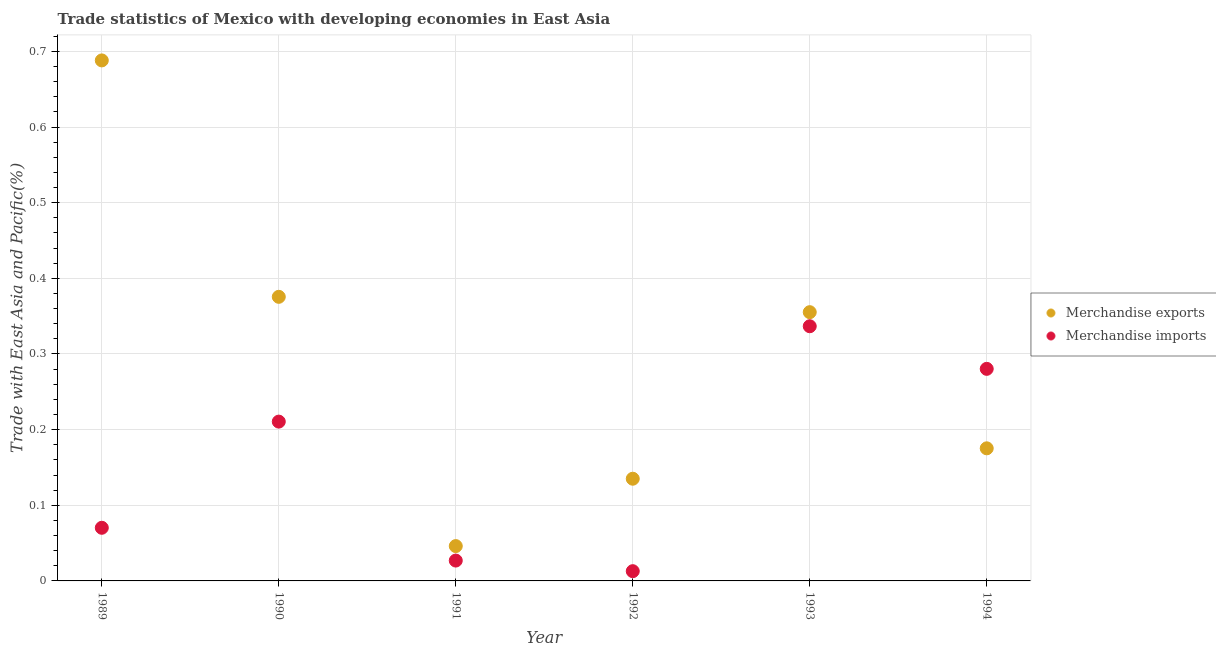What is the merchandise imports in 1993?
Offer a terse response. 0.34. Across all years, what is the maximum merchandise imports?
Provide a succinct answer. 0.34. Across all years, what is the minimum merchandise exports?
Keep it short and to the point. 0.05. In which year was the merchandise exports minimum?
Provide a succinct answer. 1991. What is the total merchandise exports in the graph?
Give a very brief answer. 1.78. What is the difference between the merchandise imports in 1989 and that in 1991?
Offer a very short reply. 0.04. What is the difference between the merchandise exports in 1993 and the merchandise imports in 1992?
Your response must be concise. 0.34. What is the average merchandise exports per year?
Give a very brief answer. 0.3. In the year 1994, what is the difference between the merchandise exports and merchandise imports?
Make the answer very short. -0.11. In how many years, is the merchandise exports greater than 0.6000000000000001 %?
Your response must be concise. 1. What is the ratio of the merchandise exports in 1992 to that in 1993?
Provide a succinct answer. 0.38. What is the difference between the highest and the second highest merchandise imports?
Give a very brief answer. 0.06. What is the difference between the highest and the lowest merchandise exports?
Your answer should be compact. 0.64. In how many years, is the merchandise imports greater than the average merchandise imports taken over all years?
Provide a short and direct response. 3. Does the merchandise exports monotonically increase over the years?
Your response must be concise. No. Is the merchandise exports strictly less than the merchandise imports over the years?
Provide a succinct answer. No. Does the graph contain grids?
Your answer should be very brief. Yes. Where does the legend appear in the graph?
Make the answer very short. Center right. How many legend labels are there?
Keep it short and to the point. 2. What is the title of the graph?
Ensure brevity in your answer.  Trade statistics of Mexico with developing economies in East Asia. Does "Register a property" appear as one of the legend labels in the graph?
Keep it short and to the point. No. What is the label or title of the X-axis?
Make the answer very short. Year. What is the label or title of the Y-axis?
Provide a short and direct response. Trade with East Asia and Pacific(%). What is the Trade with East Asia and Pacific(%) of Merchandise exports in 1989?
Give a very brief answer. 0.69. What is the Trade with East Asia and Pacific(%) in Merchandise imports in 1989?
Your answer should be very brief. 0.07. What is the Trade with East Asia and Pacific(%) of Merchandise exports in 1990?
Offer a terse response. 0.38. What is the Trade with East Asia and Pacific(%) of Merchandise imports in 1990?
Your response must be concise. 0.21. What is the Trade with East Asia and Pacific(%) in Merchandise exports in 1991?
Your answer should be very brief. 0.05. What is the Trade with East Asia and Pacific(%) of Merchandise imports in 1991?
Your answer should be very brief. 0.03. What is the Trade with East Asia and Pacific(%) of Merchandise exports in 1992?
Offer a terse response. 0.14. What is the Trade with East Asia and Pacific(%) in Merchandise imports in 1992?
Your response must be concise. 0.01. What is the Trade with East Asia and Pacific(%) of Merchandise exports in 1993?
Ensure brevity in your answer.  0.36. What is the Trade with East Asia and Pacific(%) in Merchandise imports in 1993?
Give a very brief answer. 0.34. What is the Trade with East Asia and Pacific(%) of Merchandise exports in 1994?
Provide a short and direct response. 0.18. What is the Trade with East Asia and Pacific(%) of Merchandise imports in 1994?
Provide a short and direct response. 0.28. Across all years, what is the maximum Trade with East Asia and Pacific(%) in Merchandise exports?
Provide a succinct answer. 0.69. Across all years, what is the maximum Trade with East Asia and Pacific(%) of Merchandise imports?
Ensure brevity in your answer.  0.34. Across all years, what is the minimum Trade with East Asia and Pacific(%) in Merchandise exports?
Your response must be concise. 0.05. Across all years, what is the minimum Trade with East Asia and Pacific(%) of Merchandise imports?
Your response must be concise. 0.01. What is the total Trade with East Asia and Pacific(%) of Merchandise exports in the graph?
Provide a short and direct response. 1.78. What is the total Trade with East Asia and Pacific(%) in Merchandise imports in the graph?
Your answer should be very brief. 0.94. What is the difference between the Trade with East Asia and Pacific(%) in Merchandise exports in 1989 and that in 1990?
Your response must be concise. 0.31. What is the difference between the Trade with East Asia and Pacific(%) in Merchandise imports in 1989 and that in 1990?
Give a very brief answer. -0.14. What is the difference between the Trade with East Asia and Pacific(%) in Merchandise exports in 1989 and that in 1991?
Your answer should be compact. 0.64. What is the difference between the Trade with East Asia and Pacific(%) in Merchandise imports in 1989 and that in 1991?
Your answer should be very brief. 0.04. What is the difference between the Trade with East Asia and Pacific(%) of Merchandise exports in 1989 and that in 1992?
Ensure brevity in your answer.  0.55. What is the difference between the Trade with East Asia and Pacific(%) of Merchandise imports in 1989 and that in 1992?
Offer a very short reply. 0.06. What is the difference between the Trade with East Asia and Pacific(%) in Merchandise exports in 1989 and that in 1993?
Give a very brief answer. 0.33. What is the difference between the Trade with East Asia and Pacific(%) of Merchandise imports in 1989 and that in 1993?
Provide a succinct answer. -0.27. What is the difference between the Trade with East Asia and Pacific(%) of Merchandise exports in 1989 and that in 1994?
Keep it short and to the point. 0.51. What is the difference between the Trade with East Asia and Pacific(%) of Merchandise imports in 1989 and that in 1994?
Ensure brevity in your answer.  -0.21. What is the difference between the Trade with East Asia and Pacific(%) of Merchandise exports in 1990 and that in 1991?
Provide a short and direct response. 0.33. What is the difference between the Trade with East Asia and Pacific(%) in Merchandise imports in 1990 and that in 1991?
Your response must be concise. 0.18. What is the difference between the Trade with East Asia and Pacific(%) of Merchandise exports in 1990 and that in 1992?
Give a very brief answer. 0.24. What is the difference between the Trade with East Asia and Pacific(%) of Merchandise imports in 1990 and that in 1992?
Your answer should be very brief. 0.2. What is the difference between the Trade with East Asia and Pacific(%) of Merchandise exports in 1990 and that in 1993?
Offer a terse response. 0.02. What is the difference between the Trade with East Asia and Pacific(%) in Merchandise imports in 1990 and that in 1993?
Provide a short and direct response. -0.13. What is the difference between the Trade with East Asia and Pacific(%) in Merchandise exports in 1990 and that in 1994?
Your response must be concise. 0.2. What is the difference between the Trade with East Asia and Pacific(%) in Merchandise imports in 1990 and that in 1994?
Give a very brief answer. -0.07. What is the difference between the Trade with East Asia and Pacific(%) of Merchandise exports in 1991 and that in 1992?
Make the answer very short. -0.09. What is the difference between the Trade with East Asia and Pacific(%) of Merchandise imports in 1991 and that in 1992?
Provide a short and direct response. 0.01. What is the difference between the Trade with East Asia and Pacific(%) of Merchandise exports in 1991 and that in 1993?
Your response must be concise. -0.31. What is the difference between the Trade with East Asia and Pacific(%) of Merchandise imports in 1991 and that in 1993?
Give a very brief answer. -0.31. What is the difference between the Trade with East Asia and Pacific(%) in Merchandise exports in 1991 and that in 1994?
Ensure brevity in your answer.  -0.13. What is the difference between the Trade with East Asia and Pacific(%) in Merchandise imports in 1991 and that in 1994?
Your answer should be compact. -0.25. What is the difference between the Trade with East Asia and Pacific(%) of Merchandise exports in 1992 and that in 1993?
Your response must be concise. -0.22. What is the difference between the Trade with East Asia and Pacific(%) in Merchandise imports in 1992 and that in 1993?
Give a very brief answer. -0.32. What is the difference between the Trade with East Asia and Pacific(%) in Merchandise exports in 1992 and that in 1994?
Provide a short and direct response. -0.04. What is the difference between the Trade with East Asia and Pacific(%) of Merchandise imports in 1992 and that in 1994?
Provide a succinct answer. -0.27. What is the difference between the Trade with East Asia and Pacific(%) in Merchandise exports in 1993 and that in 1994?
Provide a succinct answer. 0.18. What is the difference between the Trade with East Asia and Pacific(%) in Merchandise imports in 1993 and that in 1994?
Your answer should be very brief. 0.06. What is the difference between the Trade with East Asia and Pacific(%) in Merchandise exports in 1989 and the Trade with East Asia and Pacific(%) in Merchandise imports in 1990?
Ensure brevity in your answer.  0.48. What is the difference between the Trade with East Asia and Pacific(%) in Merchandise exports in 1989 and the Trade with East Asia and Pacific(%) in Merchandise imports in 1991?
Keep it short and to the point. 0.66. What is the difference between the Trade with East Asia and Pacific(%) of Merchandise exports in 1989 and the Trade with East Asia and Pacific(%) of Merchandise imports in 1992?
Provide a succinct answer. 0.68. What is the difference between the Trade with East Asia and Pacific(%) in Merchandise exports in 1989 and the Trade with East Asia and Pacific(%) in Merchandise imports in 1993?
Offer a terse response. 0.35. What is the difference between the Trade with East Asia and Pacific(%) of Merchandise exports in 1989 and the Trade with East Asia and Pacific(%) of Merchandise imports in 1994?
Make the answer very short. 0.41. What is the difference between the Trade with East Asia and Pacific(%) in Merchandise exports in 1990 and the Trade with East Asia and Pacific(%) in Merchandise imports in 1991?
Offer a terse response. 0.35. What is the difference between the Trade with East Asia and Pacific(%) of Merchandise exports in 1990 and the Trade with East Asia and Pacific(%) of Merchandise imports in 1992?
Give a very brief answer. 0.36. What is the difference between the Trade with East Asia and Pacific(%) of Merchandise exports in 1990 and the Trade with East Asia and Pacific(%) of Merchandise imports in 1993?
Provide a short and direct response. 0.04. What is the difference between the Trade with East Asia and Pacific(%) in Merchandise exports in 1990 and the Trade with East Asia and Pacific(%) in Merchandise imports in 1994?
Your answer should be compact. 0.1. What is the difference between the Trade with East Asia and Pacific(%) in Merchandise exports in 1991 and the Trade with East Asia and Pacific(%) in Merchandise imports in 1992?
Your answer should be compact. 0.03. What is the difference between the Trade with East Asia and Pacific(%) in Merchandise exports in 1991 and the Trade with East Asia and Pacific(%) in Merchandise imports in 1993?
Provide a short and direct response. -0.29. What is the difference between the Trade with East Asia and Pacific(%) in Merchandise exports in 1991 and the Trade with East Asia and Pacific(%) in Merchandise imports in 1994?
Ensure brevity in your answer.  -0.23. What is the difference between the Trade with East Asia and Pacific(%) in Merchandise exports in 1992 and the Trade with East Asia and Pacific(%) in Merchandise imports in 1993?
Make the answer very short. -0.2. What is the difference between the Trade with East Asia and Pacific(%) in Merchandise exports in 1992 and the Trade with East Asia and Pacific(%) in Merchandise imports in 1994?
Your answer should be very brief. -0.15. What is the difference between the Trade with East Asia and Pacific(%) of Merchandise exports in 1993 and the Trade with East Asia and Pacific(%) of Merchandise imports in 1994?
Keep it short and to the point. 0.07. What is the average Trade with East Asia and Pacific(%) of Merchandise exports per year?
Provide a succinct answer. 0.3. What is the average Trade with East Asia and Pacific(%) in Merchandise imports per year?
Offer a terse response. 0.16. In the year 1989, what is the difference between the Trade with East Asia and Pacific(%) in Merchandise exports and Trade with East Asia and Pacific(%) in Merchandise imports?
Offer a very short reply. 0.62. In the year 1990, what is the difference between the Trade with East Asia and Pacific(%) in Merchandise exports and Trade with East Asia and Pacific(%) in Merchandise imports?
Your response must be concise. 0.16. In the year 1991, what is the difference between the Trade with East Asia and Pacific(%) in Merchandise exports and Trade with East Asia and Pacific(%) in Merchandise imports?
Provide a succinct answer. 0.02. In the year 1992, what is the difference between the Trade with East Asia and Pacific(%) of Merchandise exports and Trade with East Asia and Pacific(%) of Merchandise imports?
Provide a short and direct response. 0.12. In the year 1993, what is the difference between the Trade with East Asia and Pacific(%) of Merchandise exports and Trade with East Asia and Pacific(%) of Merchandise imports?
Ensure brevity in your answer.  0.02. In the year 1994, what is the difference between the Trade with East Asia and Pacific(%) in Merchandise exports and Trade with East Asia and Pacific(%) in Merchandise imports?
Your answer should be compact. -0.11. What is the ratio of the Trade with East Asia and Pacific(%) in Merchandise exports in 1989 to that in 1990?
Provide a short and direct response. 1.83. What is the ratio of the Trade with East Asia and Pacific(%) in Merchandise imports in 1989 to that in 1990?
Provide a succinct answer. 0.33. What is the ratio of the Trade with East Asia and Pacific(%) of Merchandise exports in 1989 to that in 1991?
Give a very brief answer. 14.94. What is the ratio of the Trade with East Asia and Pacific(%) in Merchandise imports in 1989 to that in 1991?
Offer a very short reply. 2.61. What is the ratio of the Trade with East Asia and Pacific(%) of Merchandise exports in 1989 to that in 1992?
Give a very brief answer. 5.09. What is the ratio of the Trade with East Asia and Pacific(%) in Merchandise imports in 1989 to that in 1992?
Offer a very short reply. 5.45. What is the ratio of the Trade with East Asia and Pacific(%) of Merchandise exports in 1989 to that in 1993?
Offer a very short reply. 1.94. What is the ratio of the Trade with East Asia and Pacific(%) in Merchandise imports in 1989 to that in 1993?
Keep it short and to the point. 0.21. What is the ratio of the Trade with East Asia and Pacific(%) in Merchandise exports in 1989 to that in 1994?
Provide a short and direct response. 3.93. What is the ratio of the Trade with East Asia and Pacific(%) of Merchandise imports in 1989 to that in 1994?
Provide a succinct answer. 0.25. What is the ratio of the Trade with East Asia and Pacific(%) of Merchandise exports in 1990 to that in 1991?
Your answer should be very brief. 8.16. What is the ratio of the Trade with East Asia and Pacific(%) of Merchandise imports in 1990 to that in 1991?
Ensure brevity in your answer.  7.83. What is the ratio of the Trade with East Asia and Pacific(%) of Merchandise exports in 1990 to that in 1992?
Your answer should be compact. 2.78. What is the ratio of the Trade with East Asia and Pacific(%) of Merchandise imports in 1990 to that in 1992?
Make the answer very short. 16.35. What is the ratio of the Trade with East Asia and Pacific(%) in Merchandise exports in 1990 to that in 1993?
Offer a very short reply. 1.06. What is the ratio of the Trade with East Asia and Pacific(%) in Merchandise imports in 1990 to that in 1993?
Give a very brief answer. 0.63. What is the ratio of the Trade with East Asia and Pacific(%) in Merchandise exports in 1990 to that in 1994?
Offer a very short reply. 2.14. What is the ratio of the Trade with East Asia and Pacific(%) in Merchandise imports in 1990 to that in 1994?
Ensure brevity in your answer.  0.75. What is the ratio of the Trade with East Asia and Pacific(%) of Merchandise exports in 1991 to that in 1992?
Ensure brevity in your answer.  0.34. What is the ratio of the Trade with East Asia and Pacific(%) in Merchandise imports in 1991 to that in 1992?
Offer a terse response. 2.09. What is the ratio of the Trade with East Asia and Pacific(%) of Merchandise exports in 1991 to that in 1993?
Provide a succinct answer. 0.13. What is the ratio of the Trade with East Asia and Pacific(%) of Merchandise imports in 1991 to that in 1993?
Provide a short and direct response. 0.08. What is the ratio of the Trade with East Asia and Pacific(%) in Merchandise exports in 1991 to that in 1994?
Offer a very short reply. 0.26. What is the ratio of the Trade with East Asia and Pacific(%) of Merchandise imports in 1991 to that in 1994?
Your response must be concise. 0.1. What is the ratio of the Trade with East Asia and Pacific(%) in Merchandise exports in 1992 to that in 1993?
Offer a terse response. 0.38. What is the ratio of the Trade with East Asia and Pacific(%) of Merchandise imports in 1992 to that in 1993?
Ensure brevity in your answer.  0.04. What is the ratio of the Trade with East Asia and Pacific(%) of Merchandise exports in 1992 to that in 1994?
Offer a terse response. 0.77. What is the ratio of the Trade with East Asia and Pacific(%) in Merchandise imports in 1992 to that in 1994?
Offer a very short reply. 0.05. What is the ratio of the Trade with East Asia and Pacific(%) of Merchandise exports in 1993 to that in 1994?
Provide a short and direct response. 2.03. What is the ratio of the Trade with East Asia and Pacific(%) in Merchandise imports in 1993 to that in 1994?
Give a very brief answer. 1.2. What is the difference between the highest and the second highest Trade with East Asia and Pacific(%) of Merchandise exports?
Your answer should be compact. 0.31. What is the difference between the highest and the second highest Trade with East Asia and Pacific(%) of Merchandise imports?
Provide a succinct answer. 0.06. What is the difference between the highest and the lowest Trade with East Asia and Pacific(%) of Merchandise exports?
Your answer should be compact. 0.64. What is the difference between the highest and the lowest Trade with East Asia and Pacific(%) of Merchandise imports?
Your answer should be compact. 0.32. 